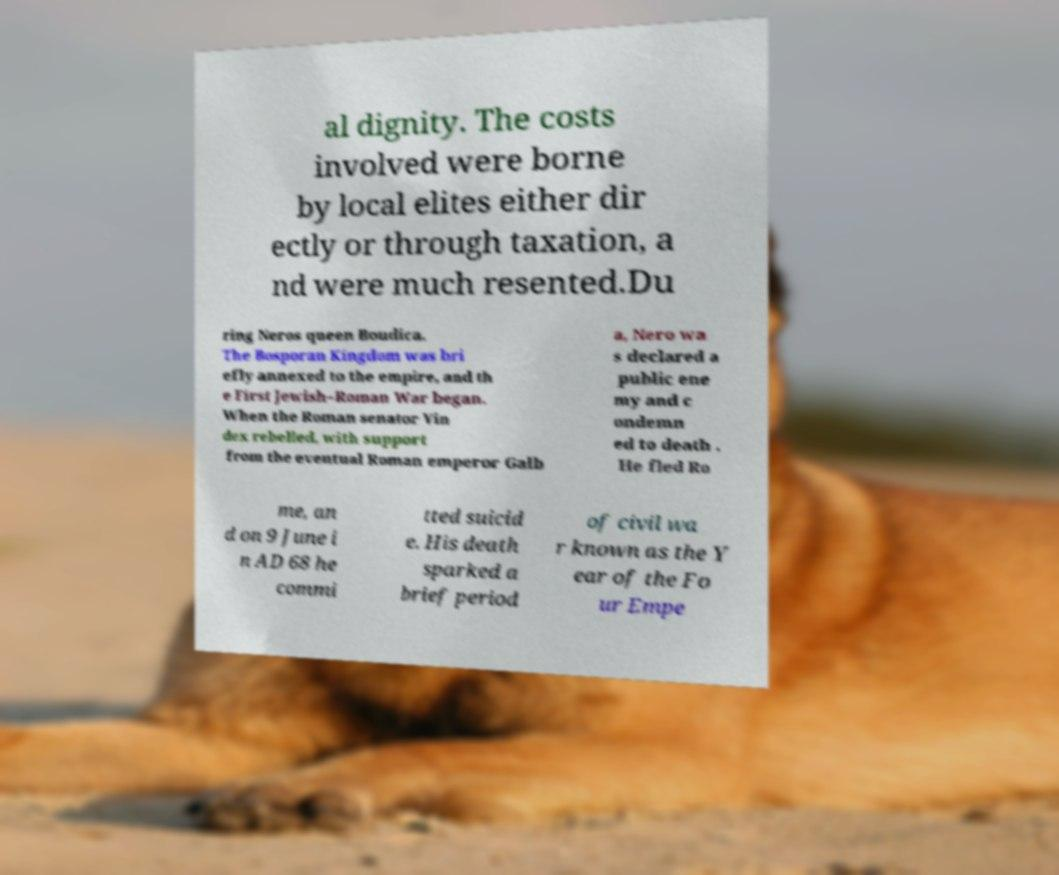Could you extract and type out the text from this image? al dignity. The costs involved were borne by local elites either dir ectly or through taxation, a nd were much resented.Du ring Neros queen Boudica. The Bosporan Kingdom was bri efly annexed to the empire, and th e First Jewish–Roman War began. When the Roman senator Vin dex rebelled, with support from the eventual Roman emperor Galb a, Nero wa s declared a public ene my and c ondemn ed to death . He fled Ro me, an d on 9 June i n AD 68 he commi tted suicid e. His death sparked a brief period of civil wa r known as the Y ear of the Fo ur Empe 